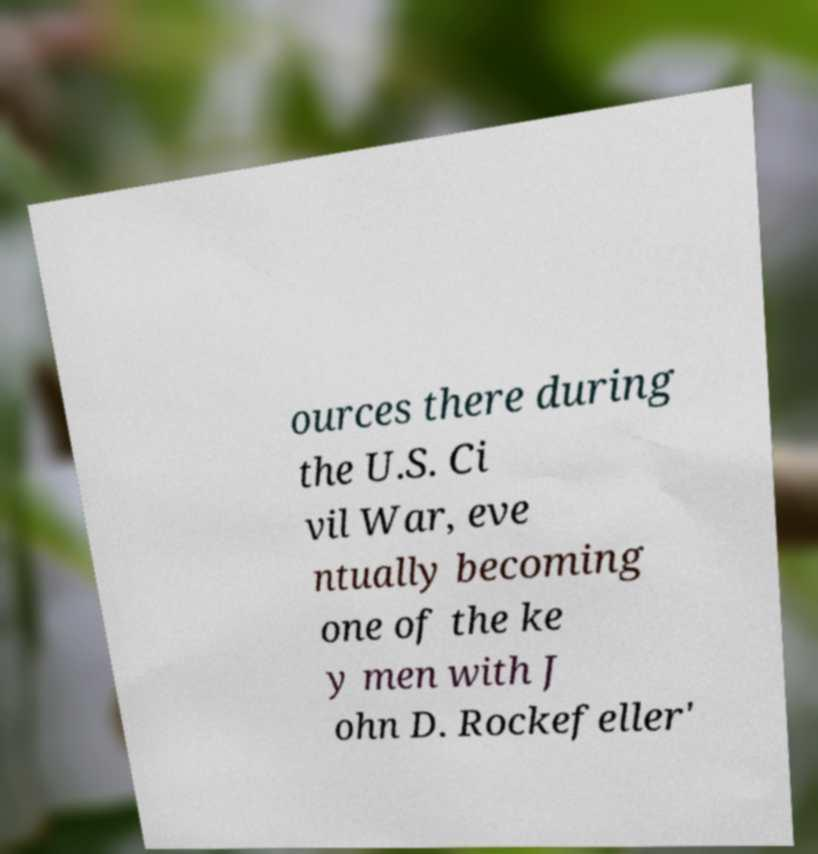Can you read and provide the text displayed in the image?This photo seems to have some interesting text. Can you extract and type it out for me? ources there during the U.S. Ci vil War, eve ntually becoming one of the ke y men with J ohn D. Rockefeller' 